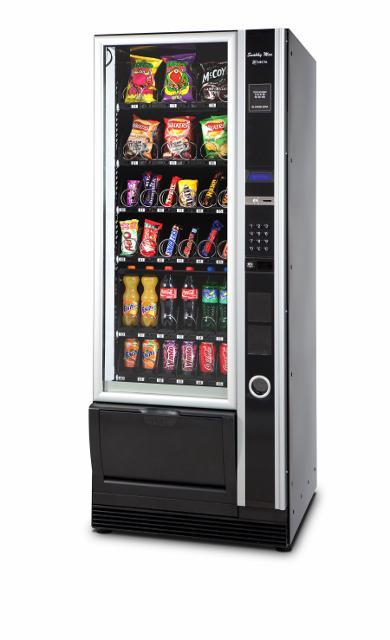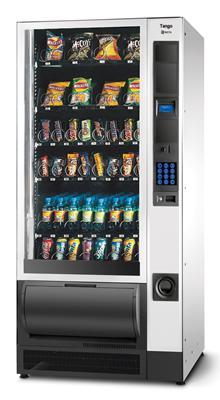The first image is the image on the left, the second image is the image on the right. Analyze the images presented: Is the assertion "The right image contains exactly one silver vending machine." valid? Answer yes or no. Yes. 